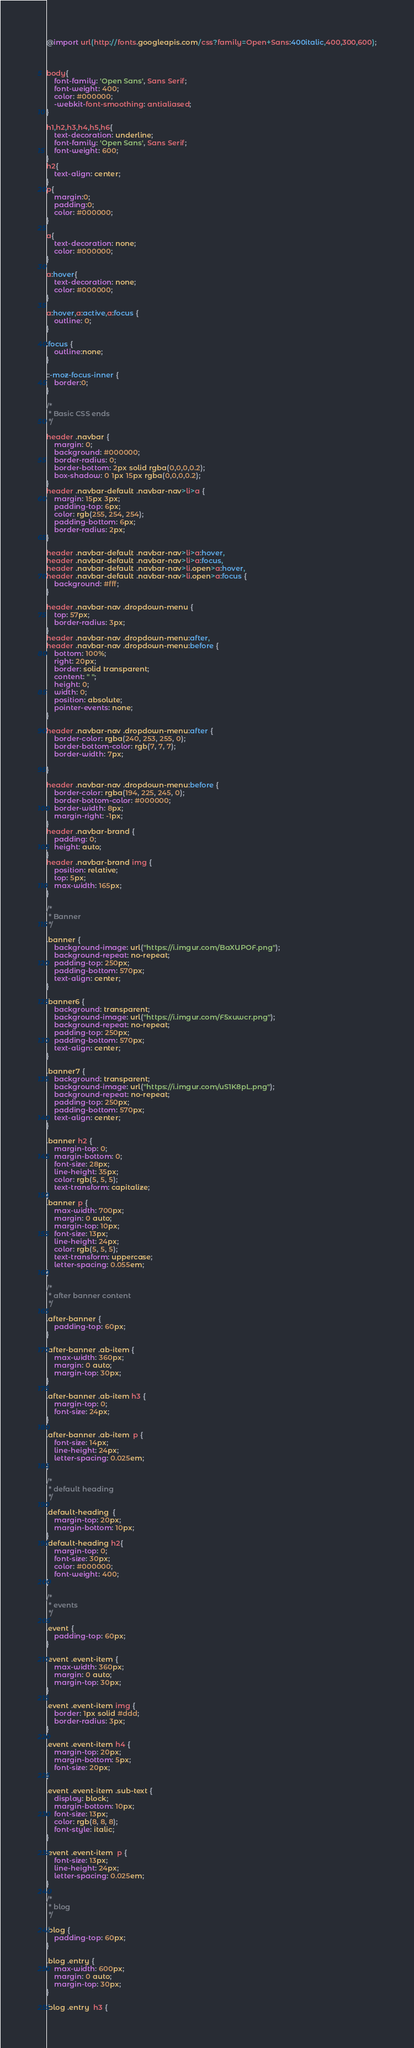Convert code to text. <code><loc_0><loc_0><loc_500><loc_500><_CSS_>
@import url(http://fonts.googleapis.com/css?family=Open+Sans:400italic,400,300,600);



body{
	font-family: 'Open Sans', Sans Serif;
	font-weight: 400;
	color: #000000;
	-webkit-font-smoothing: antialiased;
}

h1,h2,h3,h4,h5,h6{
	text-decoration: underline;
	font-family: 'Open Sans', Sans Serif;
	font-weight: 600;
}
h2{
	text-align: center;
}
p{
	margin:0;
	padding:0;
	color: #000000;
}

a{
	text-decoration: none;
	color: #000000;
}

a:hover{
	text-decoration: none;
	color: #000000;
}

a:hover,a:active,a:focus {
	outline: 0;
}

:focus {
	outline:none;
}

::-moz-focus-inner {
	border:0;
}

/* 
 * Basic CSS ends 
 */

header .navbar { 
	margin: 0;
	background: #000000;
	border-radius: 0;
	border-bottom: 2px solid rgba(0,0,0,0.2); 
	box-shadow: 0 1px 15px rgba(0,0,0,0.2);
}
header .navbar-default .navbar-nav>li>a {
	margin: 15px 3px;
	padding-top: 6px;
	color: rgb(255, 254, 254);
	padding-bottom: 6px;
	border-radius: 2px;
}

header .navbar-default .navbar-nav>li>a:hover, 
header .navbar-default .navbar-nav>li>a:focus,
header .navbar-default .navbar-nav>li.open>a:hover, 
header .navbar-default .navbar-nav>li.open>a:focus {
	background: #fff;
}

header .navbar-nav .dropdown-menu {
	top: 57px;
	border-radius: 3px;
}
header .navbar-nav .dropdown-menu:after, 
header .navbar-nav .dropdown-menu:before {
	bottom: 100%;
	right: 20px;
	border: solid transparent;
	content: " ";
	height: 0;
	width: 0;
	position: absolute;
	pointer-events: none;
}

header .navbar-nav .dropdown-menu:after {
	border-color: rgba(240, 253, 255, 0);
	border-bottom-color: rgb(7, 7, 7);
	border-width: 7px;
	
}

header .navbar-nav .dropdown-menu:before {
	border-color: rgba(194, 225, 245, 0);
	border-bottom-color: #000000;
	border-width: 8px;
	margin-right: -1px;
}
header .navbar-brand {
	padding: 0;
	height: auto;
}
header .navbar-brand img {
	position: relative;
	top: 5px;
	max-width: 165px;
}

/*
 * Banner 
 */

.banner {
	background-image: url("https://i.imgur.com/BaXUPOF.png");
	background-repeat: no-repeat;
	padding-top: 250px;
	padding-bottom: 570px;
	text-align: center;
}

.banner6 {
	background: transparent;
	background-image: url("https://i.imgur.com/F5xuwcr.png");
	background-repeat: no-repeat;
	padding-top: 250px;
	padding-bottom: 570px;
	text-align: center;
}

.banner7 {
	background: transparent;
	background-image: url("https://i.imgur.com/uS1K8pL.png");
	background-repeat: no-repeat;
	padding-top: 250px;
	padding-bottom: 570px;
	text-align: center;
}

.banner h2 {
	margin-top: 0;
	margin-bottom: 0;
	font-size: 28px;
	line-height: 35px;
	color: rgb(5, 5, 5);
	text-transform: capitalize;
}
.banner p {
	max-width: 700px;
	margin: 0 auto;
	margin-top: 10px;
	font-size: 13px;
	line-height: 24px;
	color: rgb(5, 5, 5);
	text-transform: uppercase;
	letter-spacing: 0.055em;
}

/* 
 * after banner content
 */
 
.after-banner {
	padding-top: 60px;
}

.after-banner .ab-item {
	max-width: 360px;
	margin: 0 auto;
	margin-top: 30px;
}

.after-banner .ab-item h3 {
	margin-top: 0;
	font-size: 24px;
}

.after-banner .ab-item  p {
	font-size: 14px;
	line-height: 24px;
	letter-spacing: 0.025em;
}

/*
 * default heading
 */

.default-heading  {
	margin-top: 20px;
	margin-bottom: 10px;
}
.default-heading h2{
	margin-top: 0;
	font-size: 30px;
	color: #000000;
	font-weight: 400;
}

/*
 * events
 */

.event {
	padding-top: 60px;
}

.event .event-item {
	max-width: 360px;
	margin: 0 auto;
	margin-top: 30px;
}

.event .event-item img {
	border: 1px solid #ddd;
	border-radius: 3px;
}

.event .event-item h4 {
	margin-top: 20px;
	margin-bottom: 5px;
	font-size: 20px;
}

.event .event-item .sub-text {
	display: block;
	margin-bottom: 10px;
	font-size: 13px;
	color: rgb(8, 8, 8);
	font-style: italic;
}

.event .event-item  p {
	font-size: 13px;
	line-height: 24px;
	letter-spacing: 0.025em;
}

/*
 * blog
 */

.blog {
	padding-top: 60px;
}

.blog .entry {
	max-width: 600px;
	margin: 0 auto;
	margin-top: 30px;
}

.blog .entry  h3 {</code> 